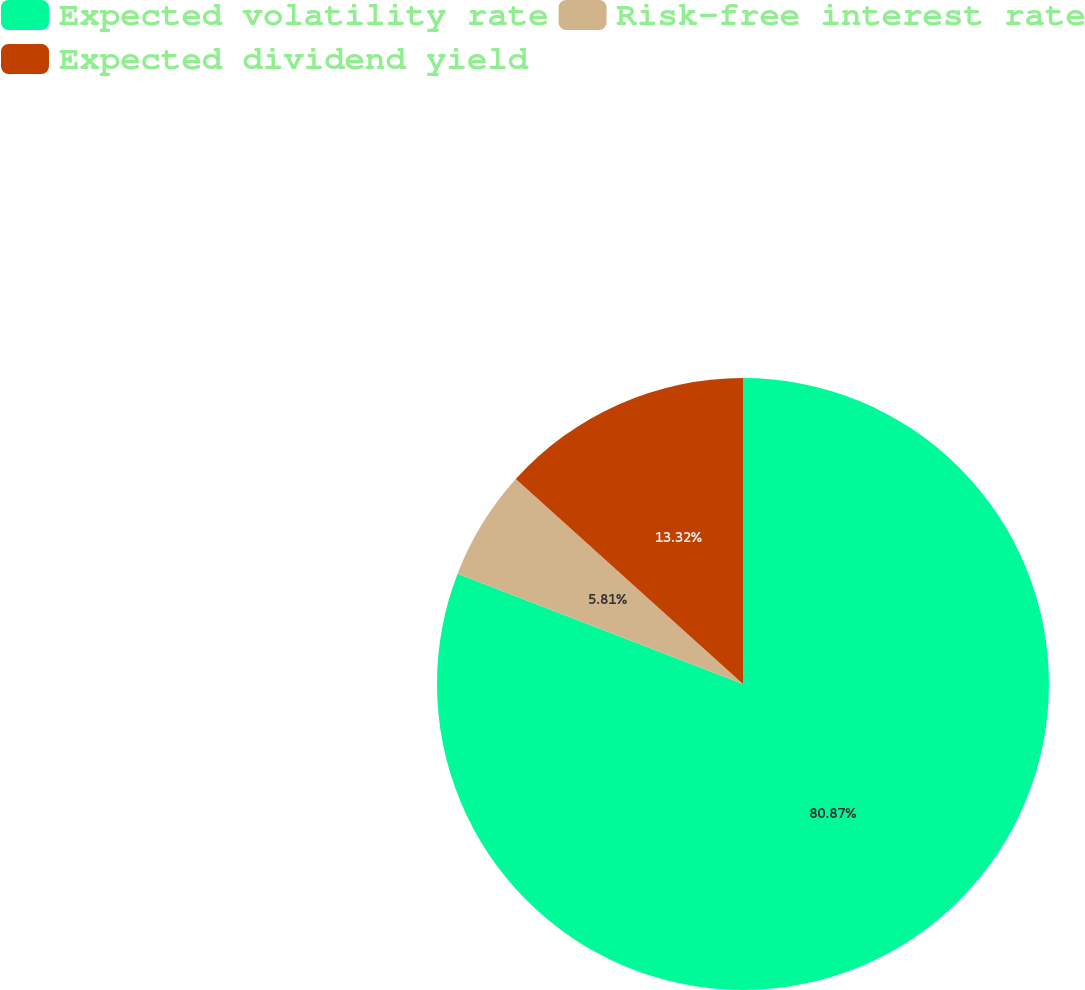Convert chart to OTSL. <chart><loc_0><loc_0><loc_500><loc_500><pie_chart><fcel>Expected volatility rate<fcel>Risk-free interest rate<fcel>Expected dividend yield<nl><fcel>80.87%<fcel>5.81%<fcel>13.32%<nl></chart> 